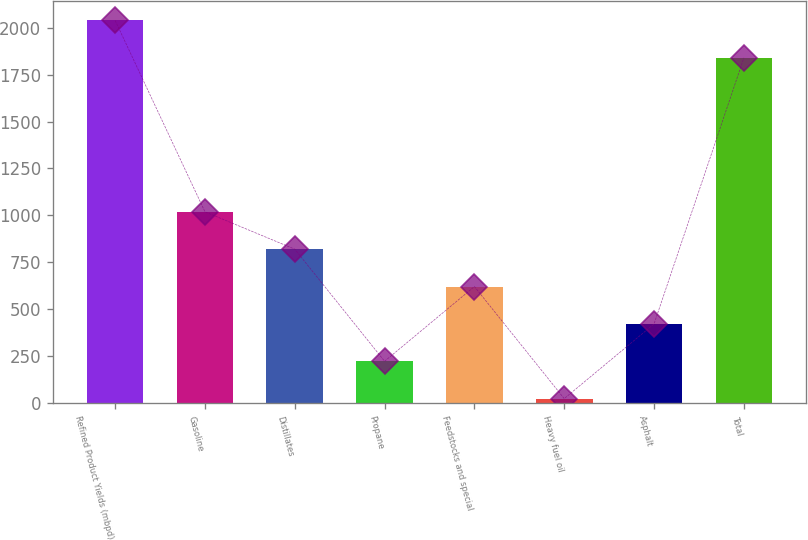Convert chart. <chart><loc_0><loc_0><loc_500><loc_500><bar_chart><fcel>Refined Product Yields (mbpd)<fcel>Gasoline<fcel>Distillates<fcel>Propane<fcel>Feedstocks and special<fcel>Heavy fuel oil<fcel>Asphalt<fcel>Total<nl><fcel>2037.9<fcel>1019.5<fcel>820.6<fcel>223.9<fcel>621.7<fcel>25<fcel>422.8<fcel>1839<nl></chart> 